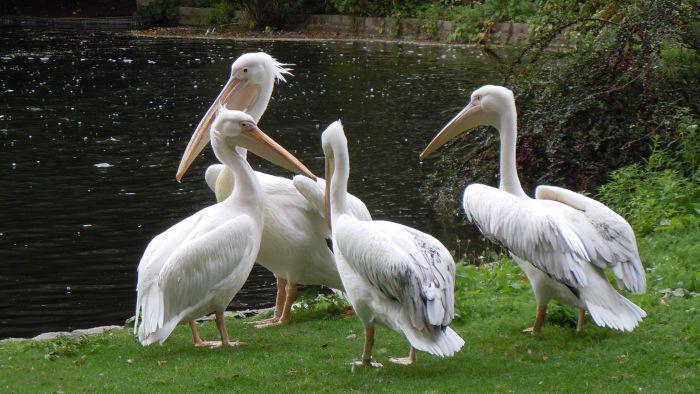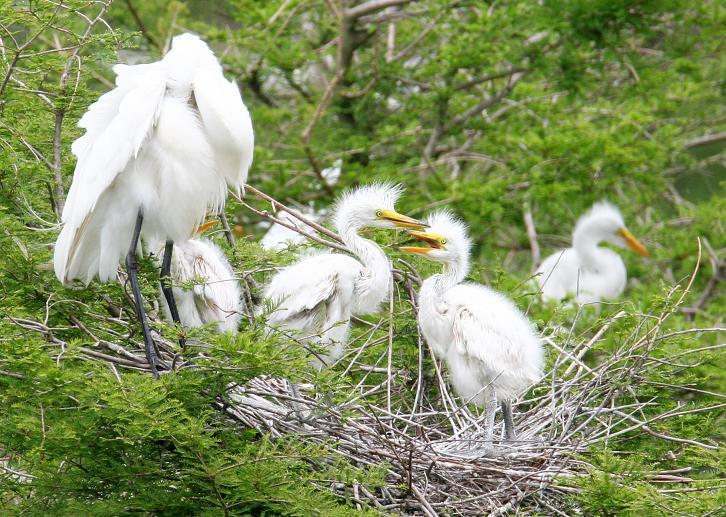The first image is the image on the left, the second image is the image on the right. For the images shown, is this caption "One of the images contain exactly 4 storks." true? Answer yes or no. Yes. The first image is the image on the left, the second image is the image on the right. Assess this claim about the two images: "One of the images shows an animal with the birds.". Correct or not? Answer yes or no. No. 